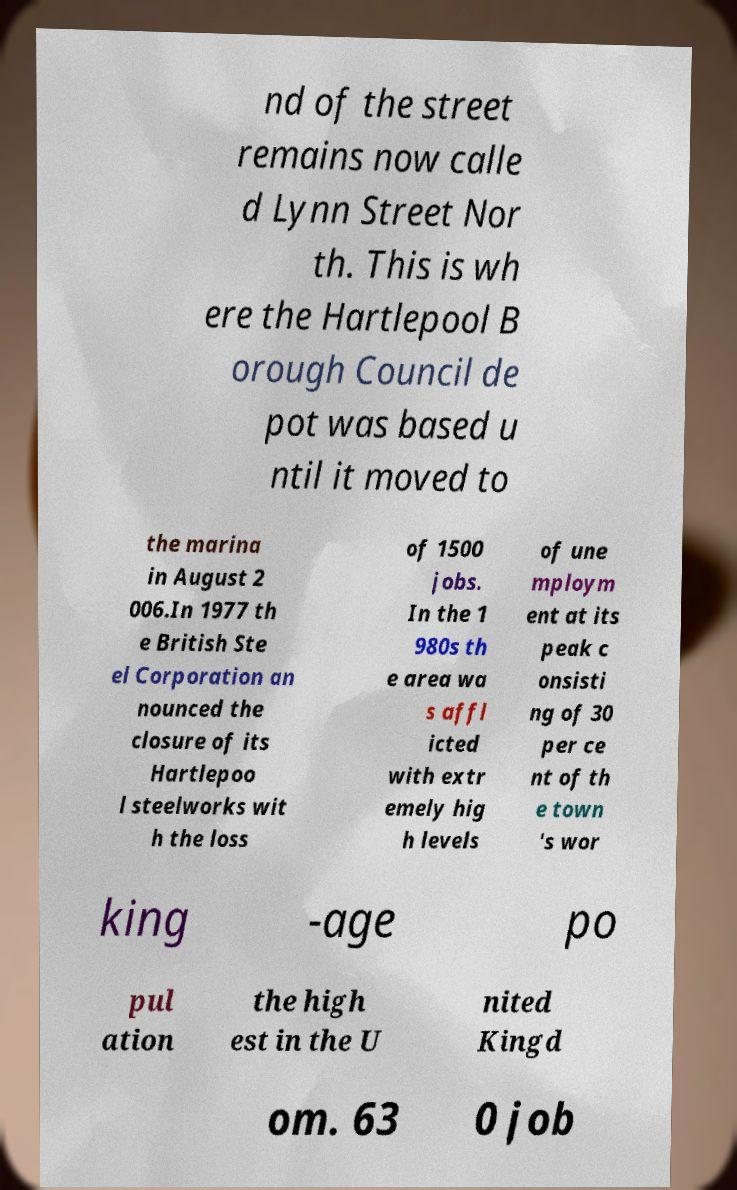There's text embedded in this image that I need extracted. Can you transcribe it verbatim? nd of the street remains now calle d Lynn Street Nor th. This is wh ere the Hartlepool B orough Council de pot was based u ntil it moved to the marina in August 2 006.In 1977 th e British Ste el Corporation an nounced the closure of its Hartlepoo l steelworks wit h the loss of 1500 jobs. In the 1 980s th e area wa s affl icted with extr emely hig h levels of une mploym ent at its peak c onsisti ng of 30 per ce nt of th e town 's wor king -age po pul ation the high est in the U nited Kingd om. 63 0 job 